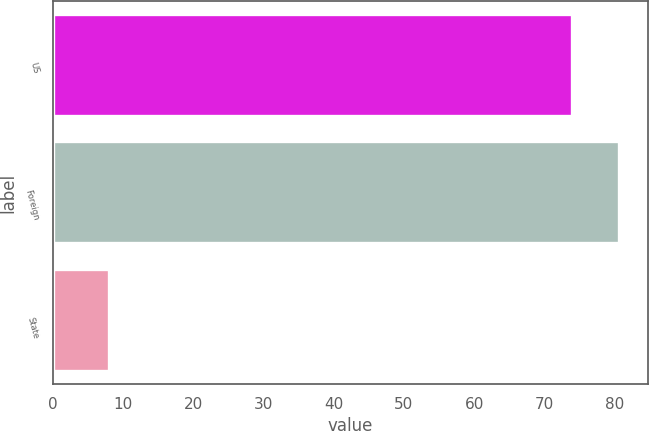Convert chart to OTSL. <chart><loc_0><loc_0><loc_500><loc_500><bar_chart><fcel>US<fcel>Foreign<fcel>State<nl><fcel>74<fcel>80.7<fcel>8<nl></chart> 